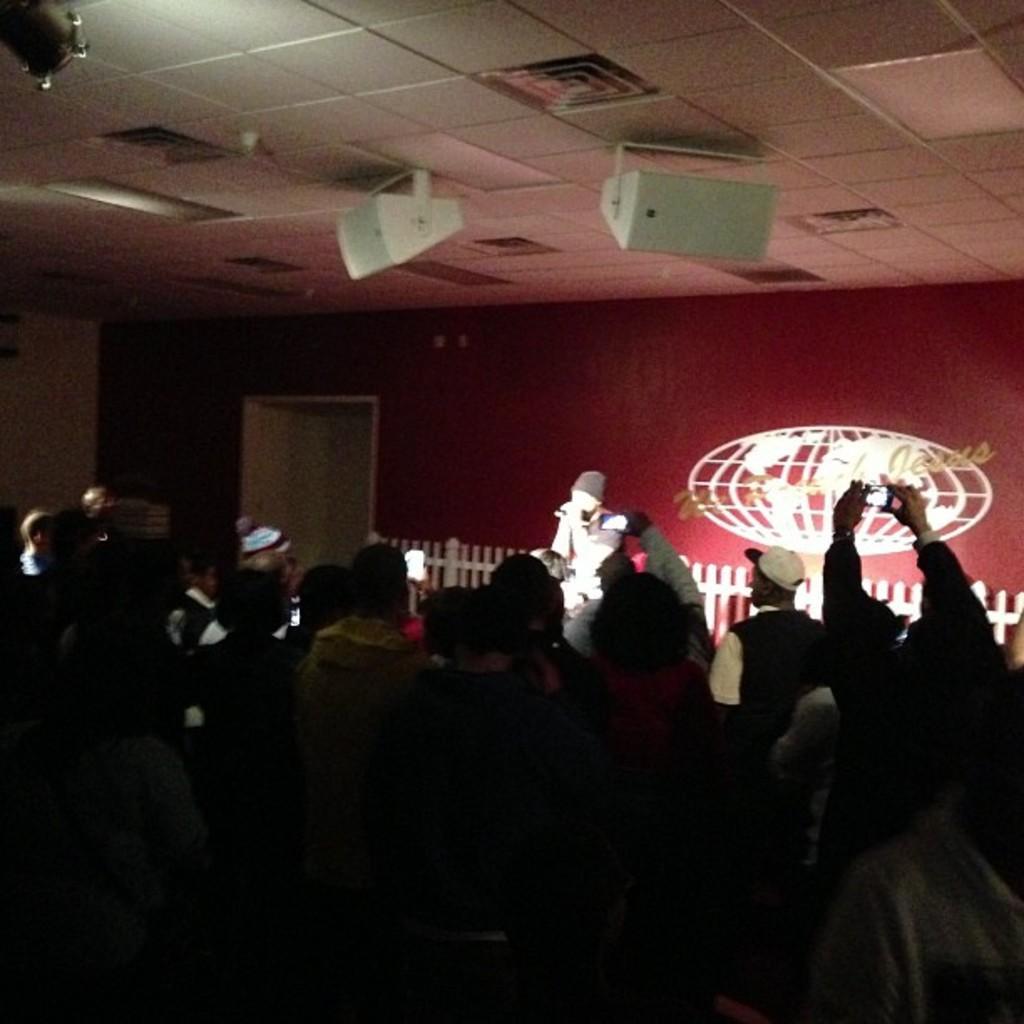Can you describe this image briefly? This is an inside view. At the bottom of the image I can see many people in the dark. In the background a person standing and holding a mike in the hands and It seems like singing. At the back of him I can see the wall and a door. Everyone is looking at the person who is singing. 